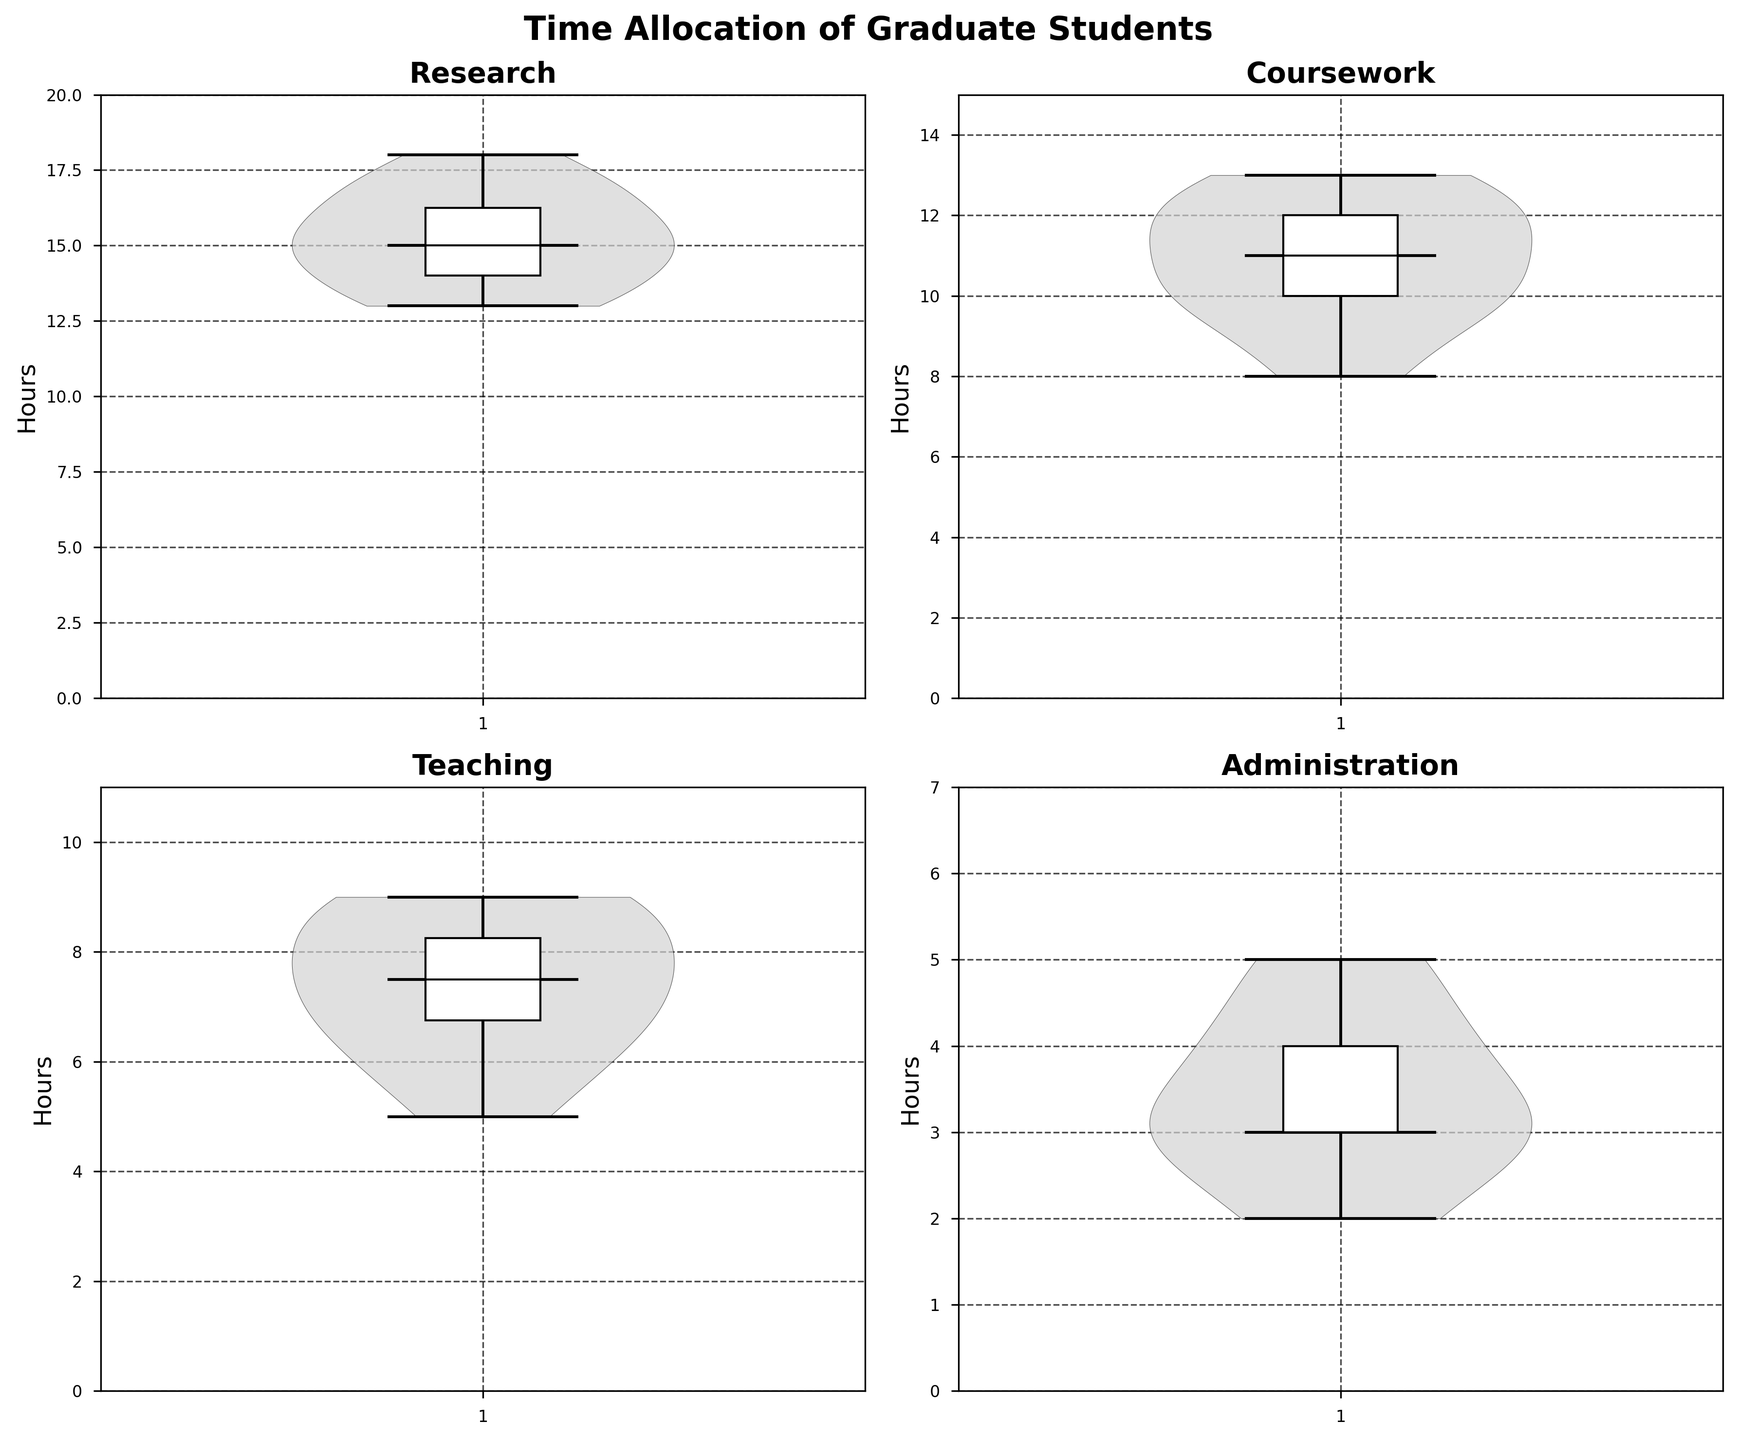What is the title of the plot? The title of the plot is located in the center at the top of the figure. It reads "Time Allocation of Graduate Students".
Answer: Time Allocation of Graduate Students Which academic task shows the highest median hours spent? The median hours for each task can be identified by the horizontal line within the violin and box plots. From the subplots, "Research" has the highest median as the median line is at 15 hours.
Answer: Research What are the minimum and maximum hours spent on teaching? The minimum and maximum values are indicated by the bottom and top ends of the violin plots. For the Teaching subplot, the minimum is 5 hours and the maximum is 9 hours.
Answer: Minimum: 5, Maximum: 9 Which task has the smallest range of hours spent? The range is the difference between the maximum and minimum hours. By visual inspection, Administration has the smallest range, spanning from 2 hours to 5 hours (a range of 3 hours).
Answer: Administration How does the interquartile range (IQR) for coursework compare to administration? The IQR is indicated by the height of the box in the box plot. For Coursework, the IQR spans from 10 to 12 hours. For Administration, it spans from 3 to 4 hours. Thus, Coursework has a larger IQR.
Answer: Coursework has a larger IQR Between which pairs of tasks is the median hours spent approximately equal? The median lines can be compared across the plots. "Coursework" and "Teaching" both have median values close to 8 hours.
Answer: Coursework and Teaching What color are the violin plots? The violin plots are shaded in light gray with a transparency effect, and the edges are outlined in black.
Answer: Light gray with black edges Which task has the widest distribution of hours spent, and how can you tell? The widest distribution can be observed by the width of the violin plot. "Research" appears to have the widest distribution as its violin plot is the widest, particularly in the middle region.
Answer: Research What is the most common task that students spend approximately 10 hours on? Reviewing the violin plots, "Coursework" has the highest density around 10 hours, indicating that most students spend close to that amount of time on coursework.
Answer: Coursework 